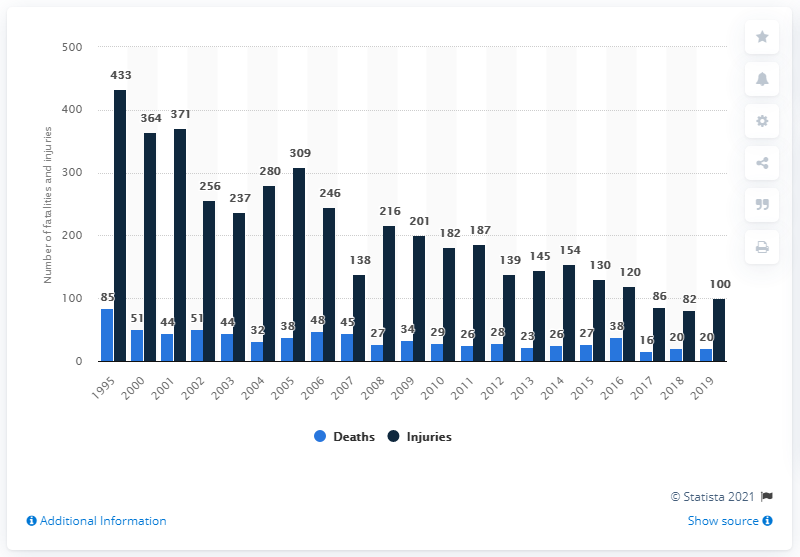List a handful of essential elements in this visual. There were approximately 20,000 deaths due to lightning in the United States between 1995 and 2019. In 2019, there were 100 reported injuries in the United States caused by lightning. 